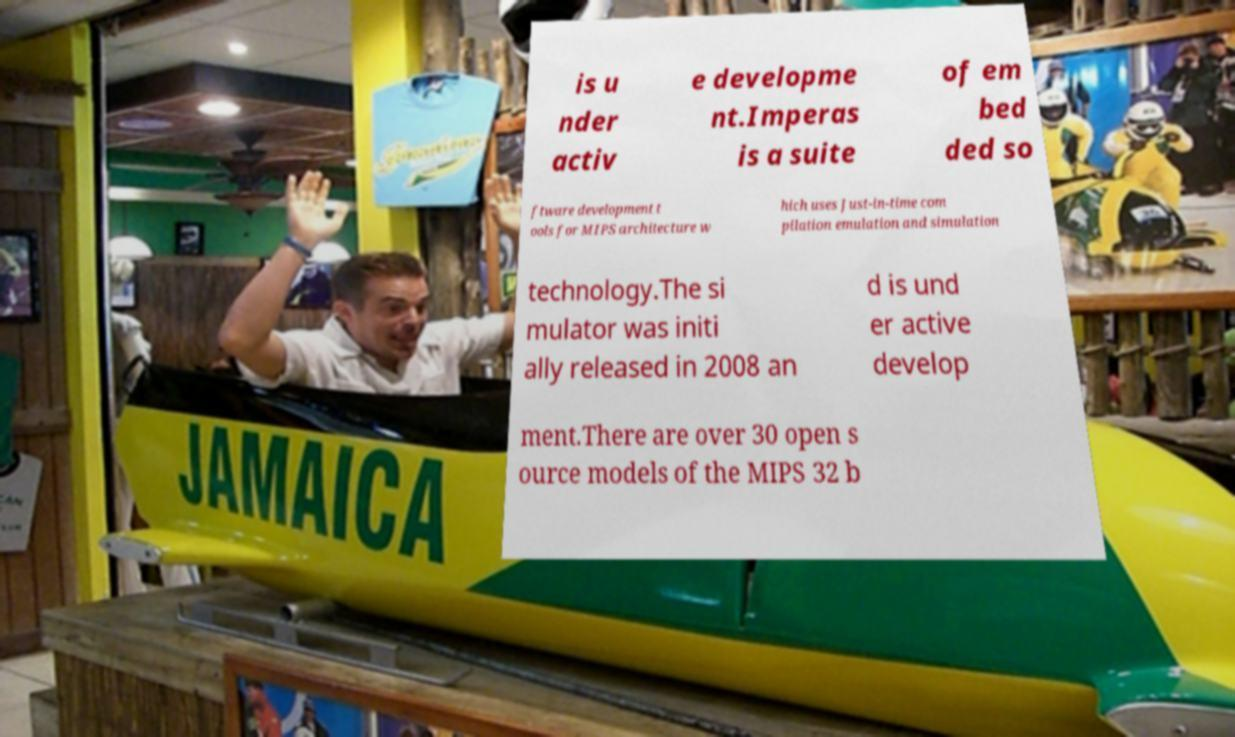Could you extract and type out the text from this image? is u nder activ e developme nt.Imperas is a suite of em bed ded so ftware development t ools for MIPS architecture w hich uses Just-in-time com pilation emulation and simulation technology.The si mulator was initi ally released in 2008 an d is und er active develop ment.There are over 30 open s ource models of the MIPS 32 b 